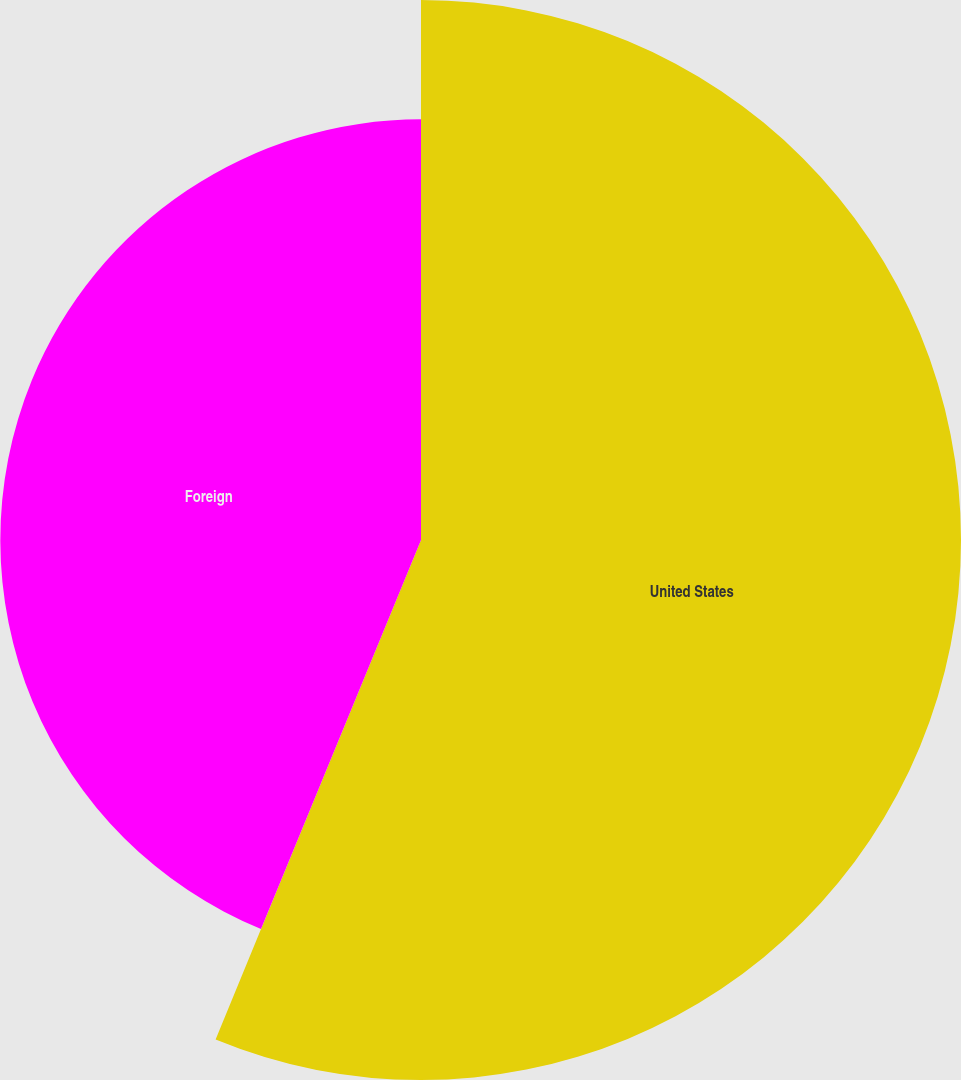Convert chart to OTSL. <chart><loc_0><loc_0><loc_500><loc_500><pie_chart><fcel>United States<fcel>Foreign<nl><fcel>56.21%<fcel>43.79%<nl></chart> 